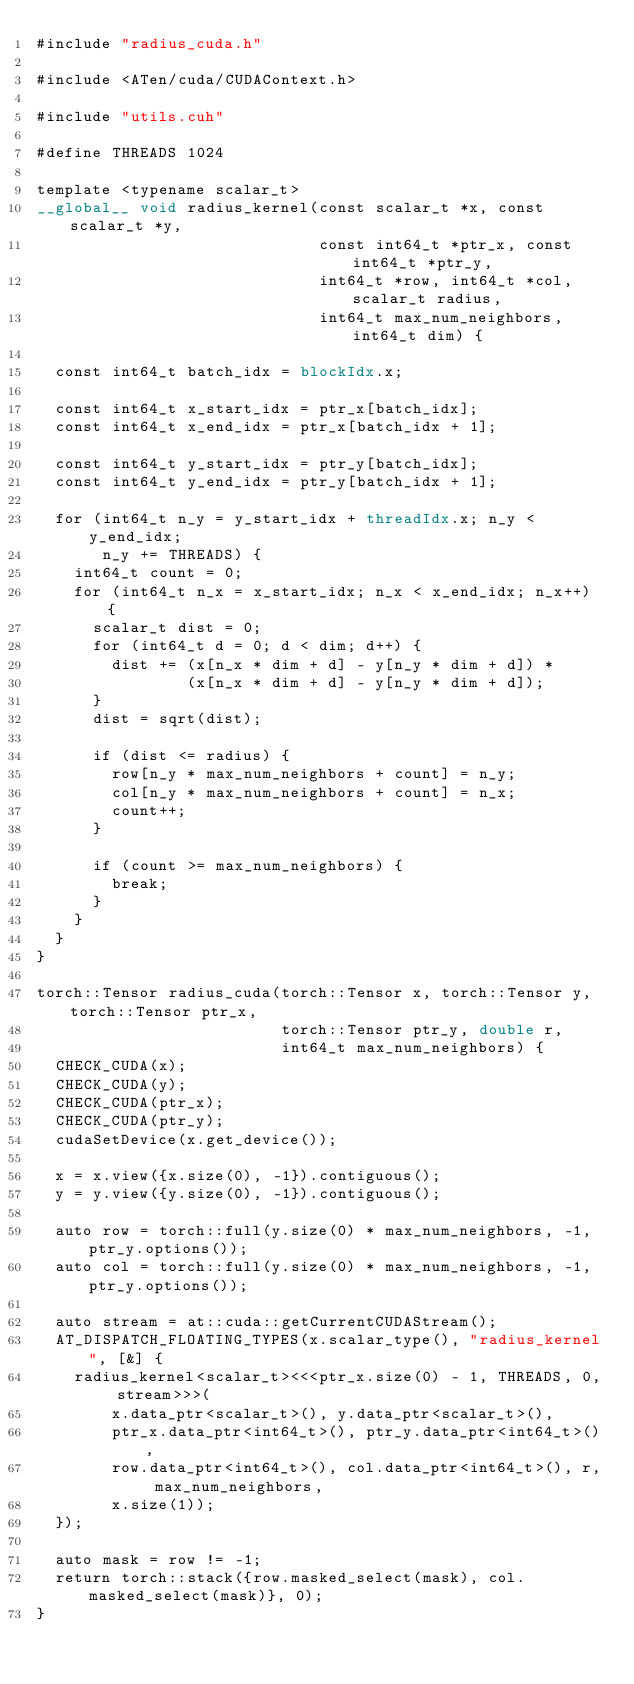<code> <loc_0><loc_0><loc_500><loc_500><_Cuda_>#include "radius_cuda.h"

#include <ATen/cuda/CUDAContext.h>

#include "utils.cuh"

#define THREADS 1024

template <typename scalar_t>
__global__ void radius_kernel(const scalar_t *x, const scalar_t *y,
                              const int64_t *ptr_x, const int64_t *ptr_y,
                              int64_t *row, int64_t *col, scalar_t radius,
                              int64_t max_num_neighbors, int64_t dim) {

  const int64_t batch_idx = blockIdx.x;

  const int64_t x_start_idx = ptr_x[batch_idx];
  const int64_t x_end_idx = ptr_x[batch_idx + 1];

  const int64_t y_start_idx = ptr_y[batch_idx];
  const int64_t y_end_idx = ptr_y[batch_idx + 1];

  for (int64_t n_y = y_start_idx + threadIdx.x; n_y < y_end_idx;
       n_y += THREADS) {
    int64_t count = 0;
    for (int64_t n_x = x_start_idx; n_x < x_end_idx; n_x++) {
      scalar_t dist = 0;
      for (int64_t d = 0; d < dim; d++) {
        dist += (x[n_x * dim + d] - y[n_y * dim + d]) *
                (x[n_x * dim + d] - y[n_y * dim + d]);
      }
      dist = sqrt(dist);

      if (dist <= radius) {
        row[n_y * max_num_neighbors + count] = n_y;
        col[n_y * max_num_neighbors + count] = n_x;
        count++;
      }

      if (count >= max_num_neighbors) {
        break;
      }
    }
  }
}

torch::Tensor radius_cuda(torch::Tensor x, torch::Tensor y, torch::Tensor ptr_x,
                          torch::Tensor ptr_y, double r,
                          int64_t max_num_neighbors) {
  CHECK_CUDA(x);
  CHECK_CUDA(y);
  CHECK_CUDA(ptr_x);
  CHECK_CUDA(ptr_y);
  cudaSetDevice(x.get_device());

  x = x.view({x.size(0), -1}).contiguous();
  y = y.view({y.size(0), -1}).contiguous();

  auto row = torch::full(y.size(0) * max_num_neighbors, -1, ptr_y.options());
  auto col = torch::full(y.size(0) * max_num_neighbors, -1, ptr_y.options());

  auto stream = at::cuda::getCurrentCUDAStream();
  AT_DISPATCH_FLOATING_TYPES(x.scalar_type(), "radius_kernel", [&] {
    radius_kernel<scalar_t><<<ptr_x.size(0) - 1, THREADS, 0, stream>>>(
        x.data_ptr<scalar_t>(), y.data_ptr<scalar_t>(),
        ptr_x.data_ptr<int64_t>(), ptr_y.data_ptr<int64_t>(),
        row.data_ptr<int64_t>(), col.data_ptr<int64_t>(), r, max_num_neighbors,
        x.size(1));
  });

  auto mask = row != -1;
  return torch::stack({row.masked_select(mask), col.masked_select(mask)}, 0);
}
</code> 